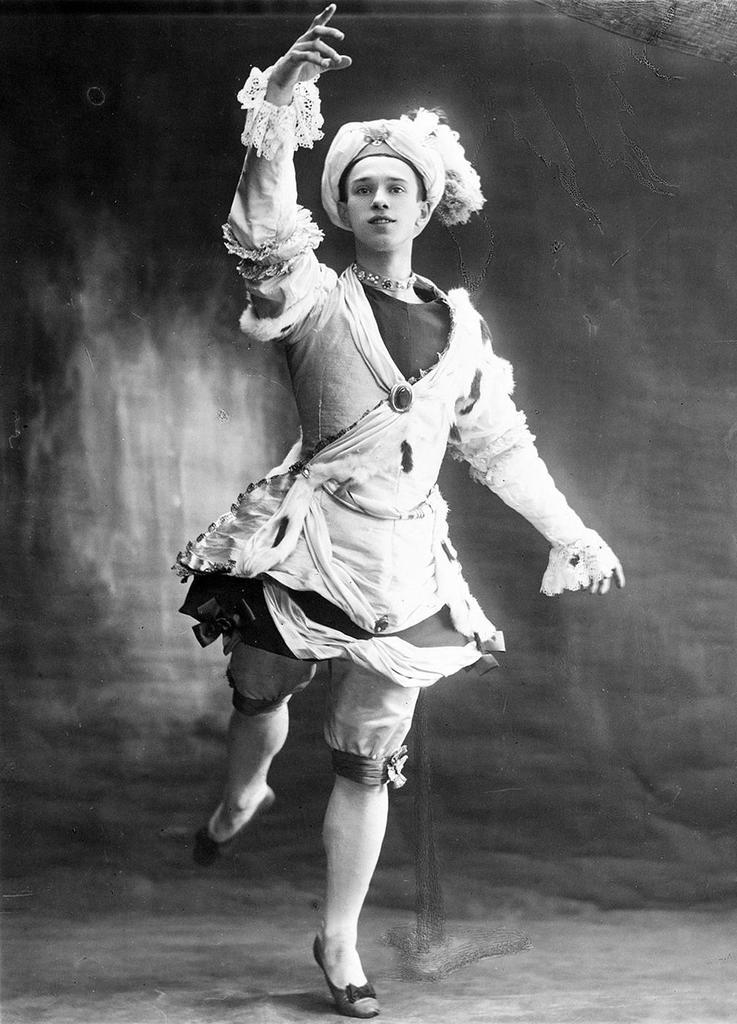What is the color scheme of the image? The image is black and white. Who is present in the image? There is a man in the image. What is the man doing in the image? The man is dancing. What is the man wearing in the image? The man is wearing a fancy dress. What can be observed about the background of the image? The background of the image appears black in color. What type of structure is the man trying to push in the image? There is no structure present in the image, and the man is not shown pushing anything. 